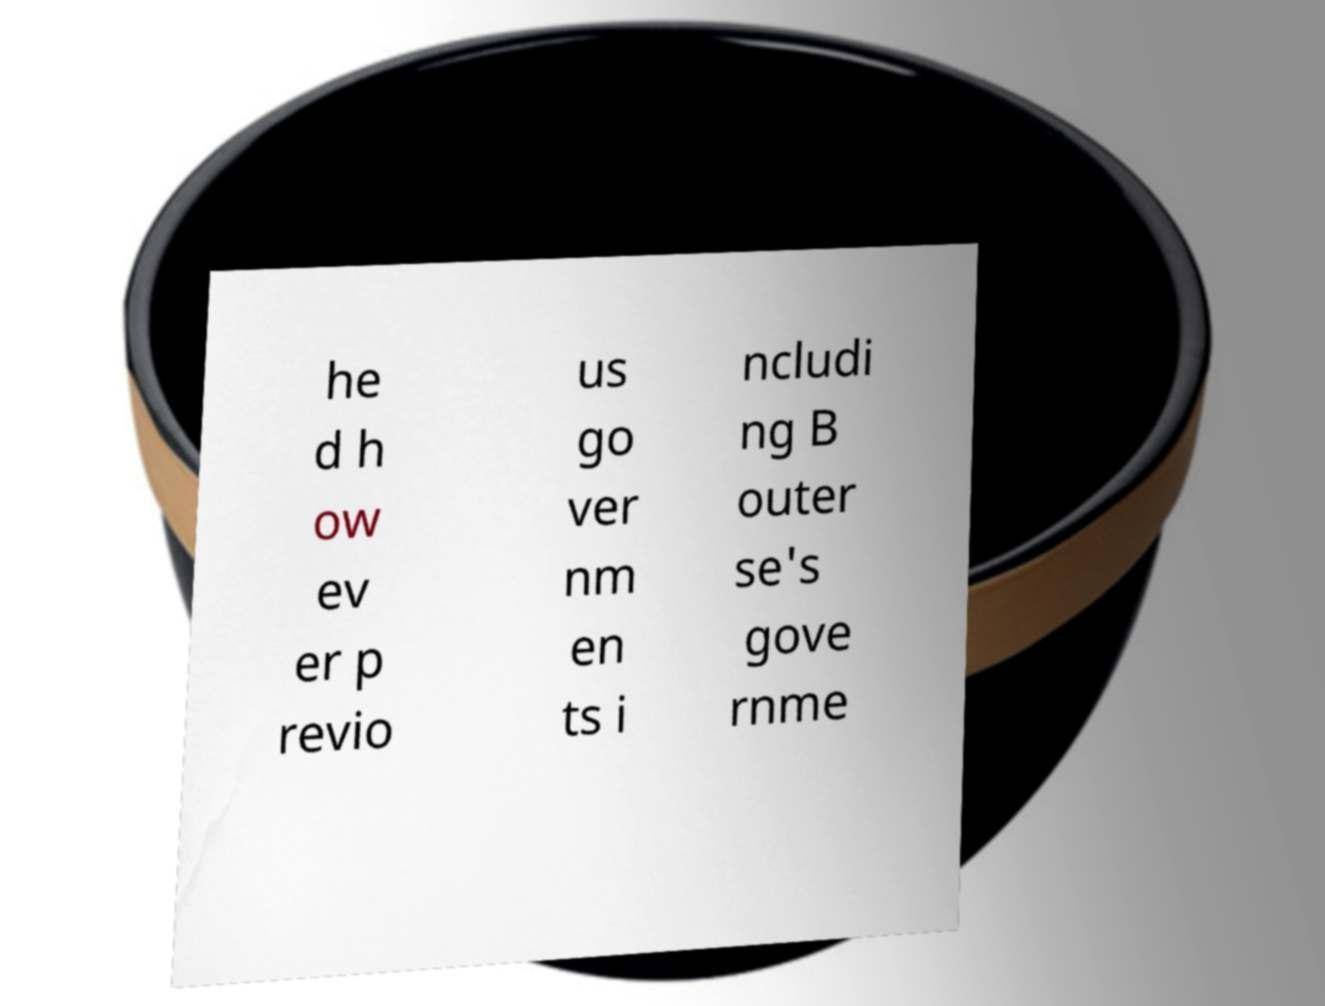There's text embedded in this image that I need extracted. Can you transcribe it verbatim? he d h ow ev er p revio us go ver nm en ts i ncludi ng B outer se's gove rnme 